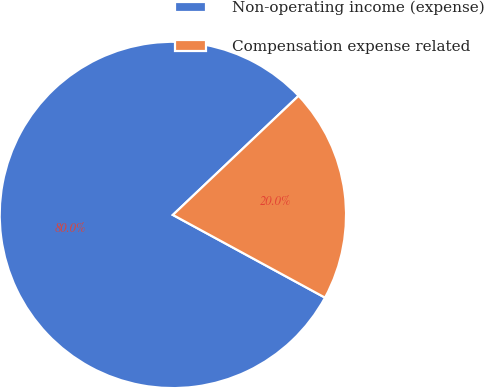Convert chart. <chart><loc_0><loc_0><loc_500><loc_500><pie_chart><fcel>Non-operating income (expense)<fcel>Compensation expense related<nl><fcel>80.0%<fcel>20.0%<nl></chart> 